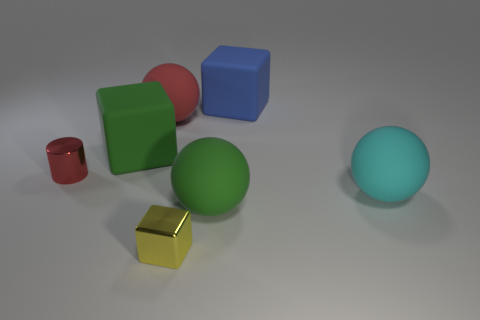There is a green cube that is the same size as the blue block; what is its material?
Make the answer very short. Rubber. There is a red thing left of the matte ball behind the metal object that is behind the yellow thing; how big is it?
Ensure brevity in your answer.  Small. Do the big rubber sphere behind the red shiny cylinder and the shiny object behind the tiny yellow thing have the same color?
Your response must be concise. Yes. What number of yellow objects are matte balls or tiny cylinders?
Provide a succinct answer. 0. How many green rubber cubes are the same size as the cylinder?
Give a very brief answer. 0. Is the ball behind the small metal cylinder made of the same material as the large green block?
Your response must be concise. Yes. Are there any big cyan matte objects that are to the right of the rubber sphere in front of the big cyan thing?
Your answer should be very brief. Yes. There is a tiny object that is the same shape as the large blue thing; what is its material?
Ensure brevity in your answer.  Metal. Are there more tiny things that are to the right of the tiny red metal object than yellow metal objects behind the large green rubber block?
Ensure brevity in your answer.  Yes. What shape is the red object that is made of the same material as the blue cube?
Offer a very short reply. Sphere. 